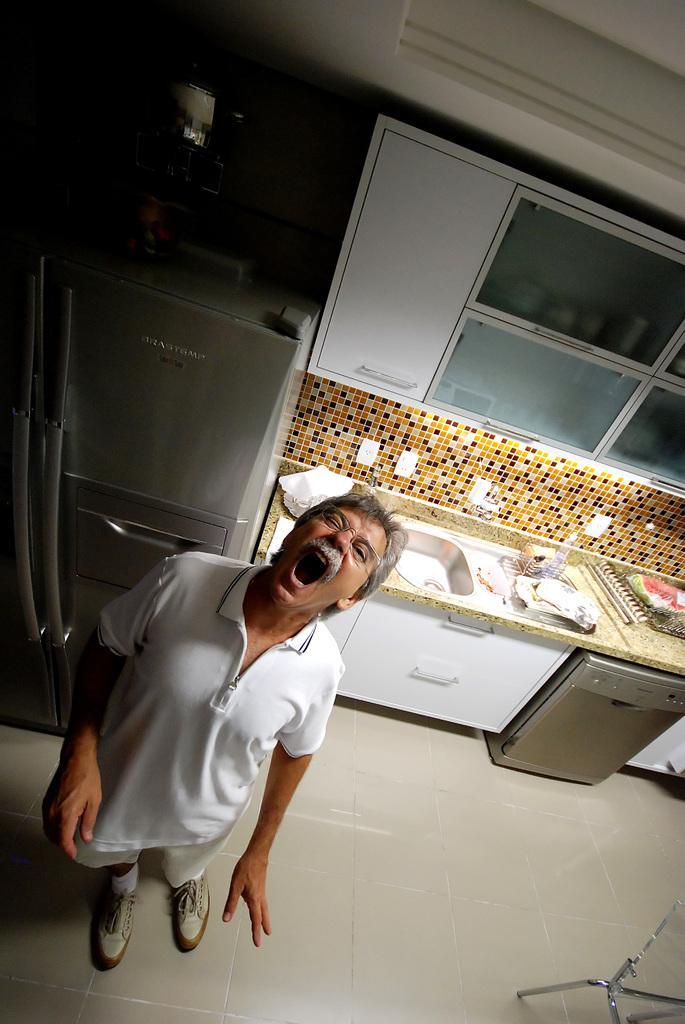Can you describe this image briefly? In this image we can see a man is standing on the white surface. He is wearing white color t-shirt. Behind him refrigerator, cupboard and kitchen counter is there. On kitchen counter things are kept and sink is there. Right bottom of the image one chair is present. 